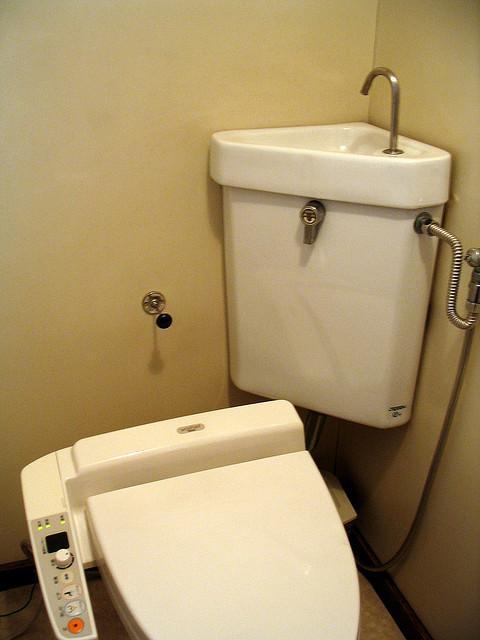How many girls are there?
Give a very brief answer. 0. 